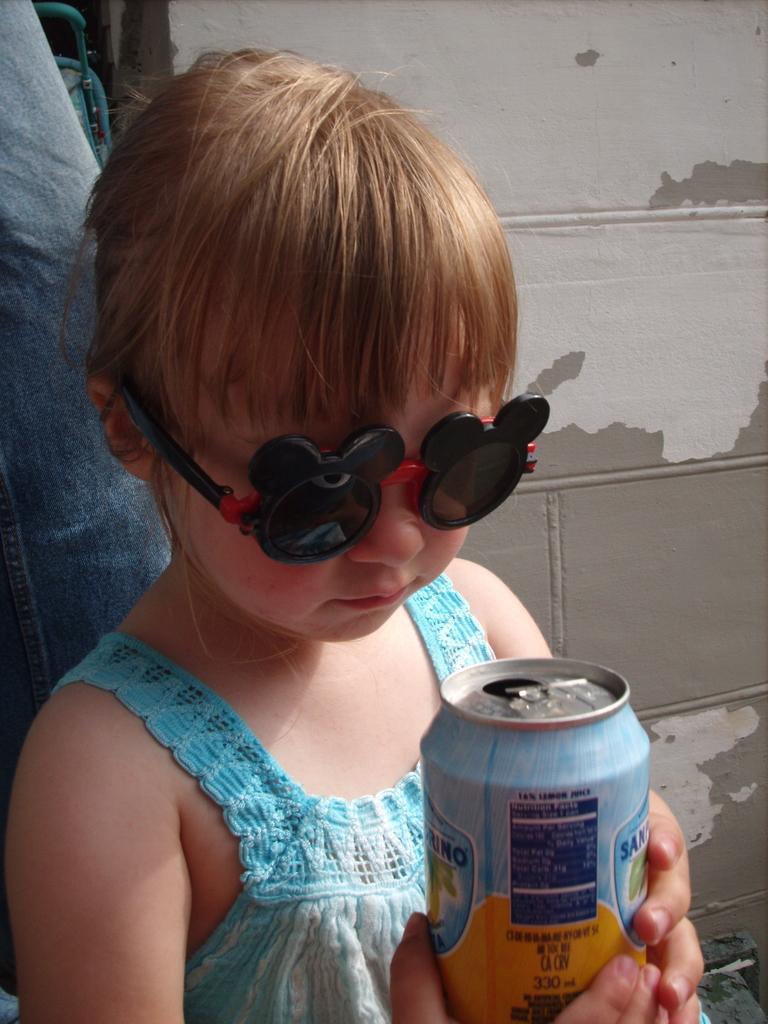How would you summarize this image in a sentence or two? In the foreground of this image, there is a kid holding a tin and wearing spectacles. In the background, there is a leg of a person and a wall. 